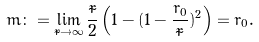<formula> <loc_0><loc_0><loc_500><loc_500>m \colon = \lim _ { \tilde { r } \to \infty } \frac { \tilde { r } } 2 \left ( 1 - ( 1 - \frac { r _ { 0 } } { \tilde { r } } ) ^ { 2 } \right ) = r _ { 0 } .</formula> 